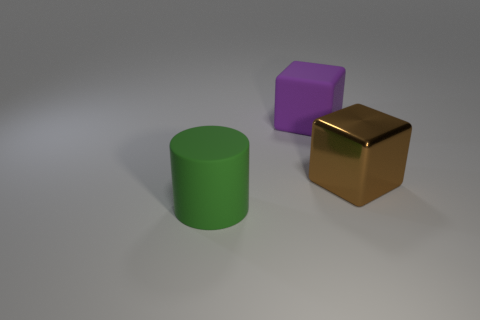What time of day does the lighting in the image suggest, if this were an outdoor scene? If this were an outdoor scene, the diffused lighting with the shadows directly beneath the objects might suggest it is around noon, when the sun is typically at its highest point in the sky. 